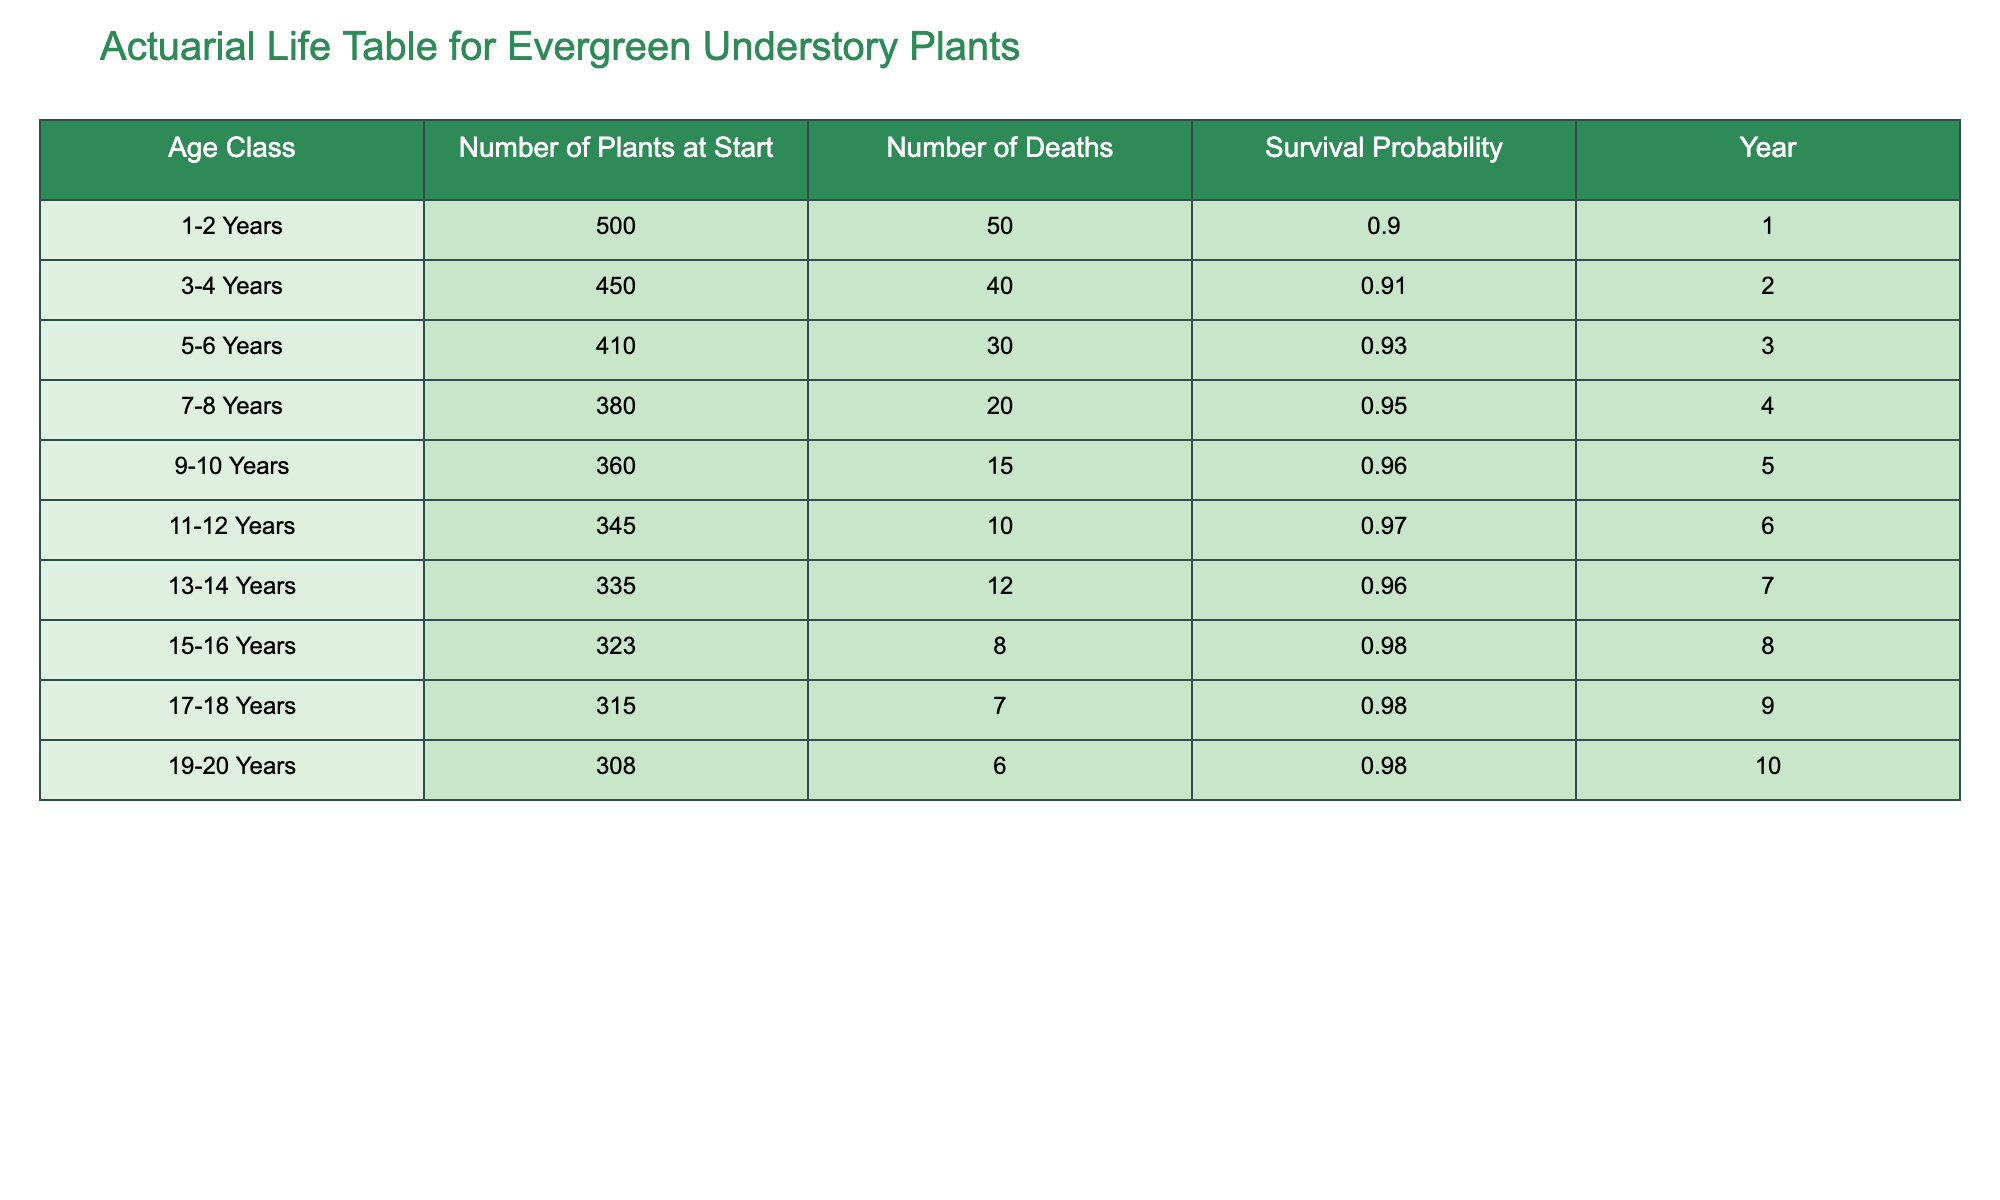What is the survival probability for plants aged 9-10 years? Referring to the table, the survival probability column lists the values for each age class. For the age class of 9-10 years, the survival probability is directly stated in the table as 0.96.
Answer: 0.96 How many plants aged 7-8 years died? The table indicates the number of deaths for each age class. For the 7-8 years age class, the number of deaths is listed as 20.
Answer: 20 What is the total number of plants that died from ages 1-2 years to 19-20 years? To find the total number of deaths across specified age classes, we sum the number of deaths: 50 (1-2 years) + 40 (3-4 years) + 30 (5-6 years) + 20 (7-8 years) + 15 (9-10 years) + 10 (11-12 years) + 12 (13-14 years) + 8 (15-16 years) + 7 (17-18 years) + 6 (19-20 years) = 298.
Answer: 298 Is the survival probability increasing over time? To determine this, we must look at the survival probabilities from the table. Comparing the probabilities, they are 0.90 (1-2 years), 0.91 (3-4 years), 0.93 (5-6 years), 0.95 (7-8 years), 0.96 (9-10 years), 0.97 (11-12 years), 0.96 (13-14 years), 0.98 (15-16 years), 0.98 (17-18 years), and 0.98 (19-20 years). Overall, they show an increasing trend, especially until 12 years old, with some stabilization afterwards. Thus, the answer is yes, with an initial increase.
Answer: Yes What is the average number of plants at the start for all age classes? To find the average, we first sum the number of plants at the start: 500 (1-2 years) + 450 (3-4 years) + 410 (5-6 years) + 380 (7-8 years) + 360 (9-10 years) + 345 (11-12 years) + 335 (13-14 years) + 323 (15-16 years) + 315 (17-18 years) + 308 (19-20 years) = 4,277. There are 10 age classes, so the average is 4,277/10 = 427.7.
Answer: 427.7 